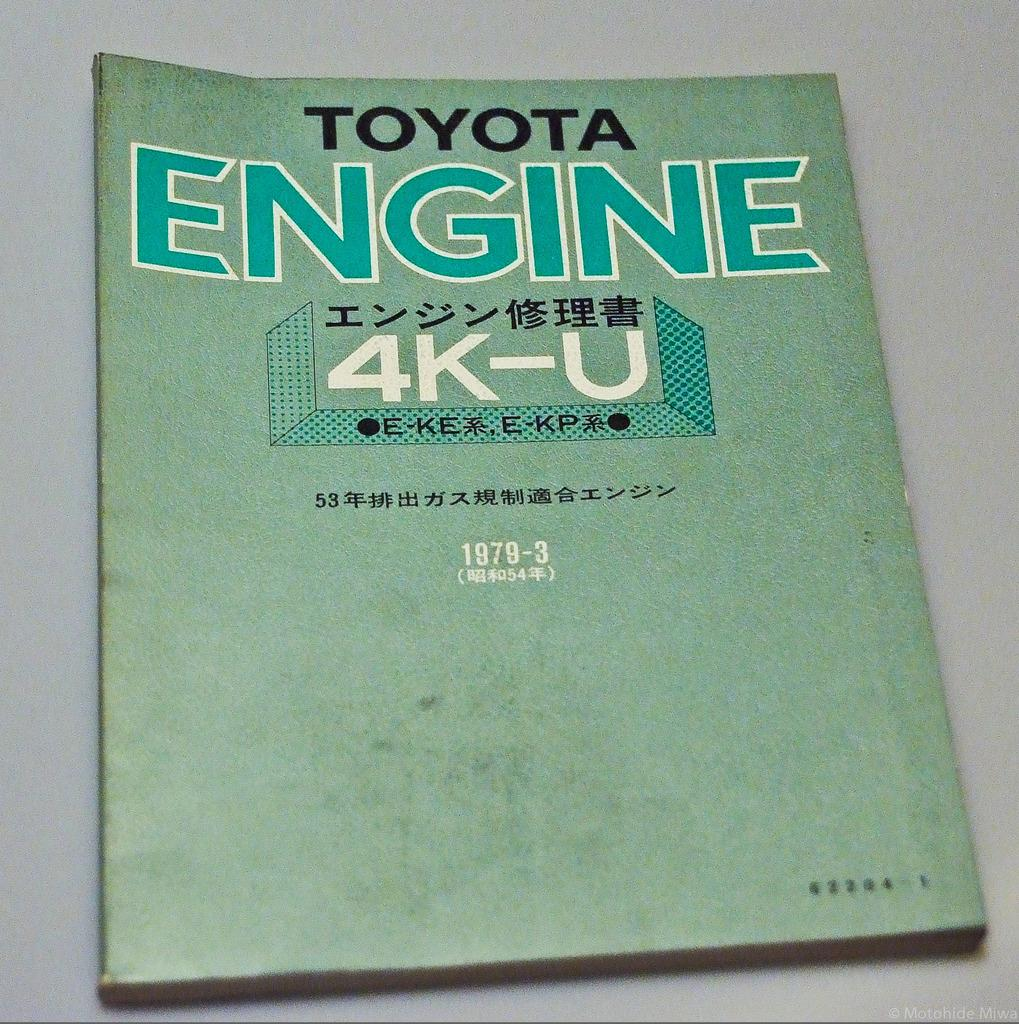<image>
Relay a brief, clear account of the picture shown. An old green Toyota Engine 4K-U 1979-3 manual. 